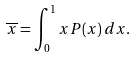<formula> <loc_0><loc_0><loc_500><loc_500>\overline { x } = \int _ { 0 } ^ { 1 } x P ( x ) \, d x .</formula> 